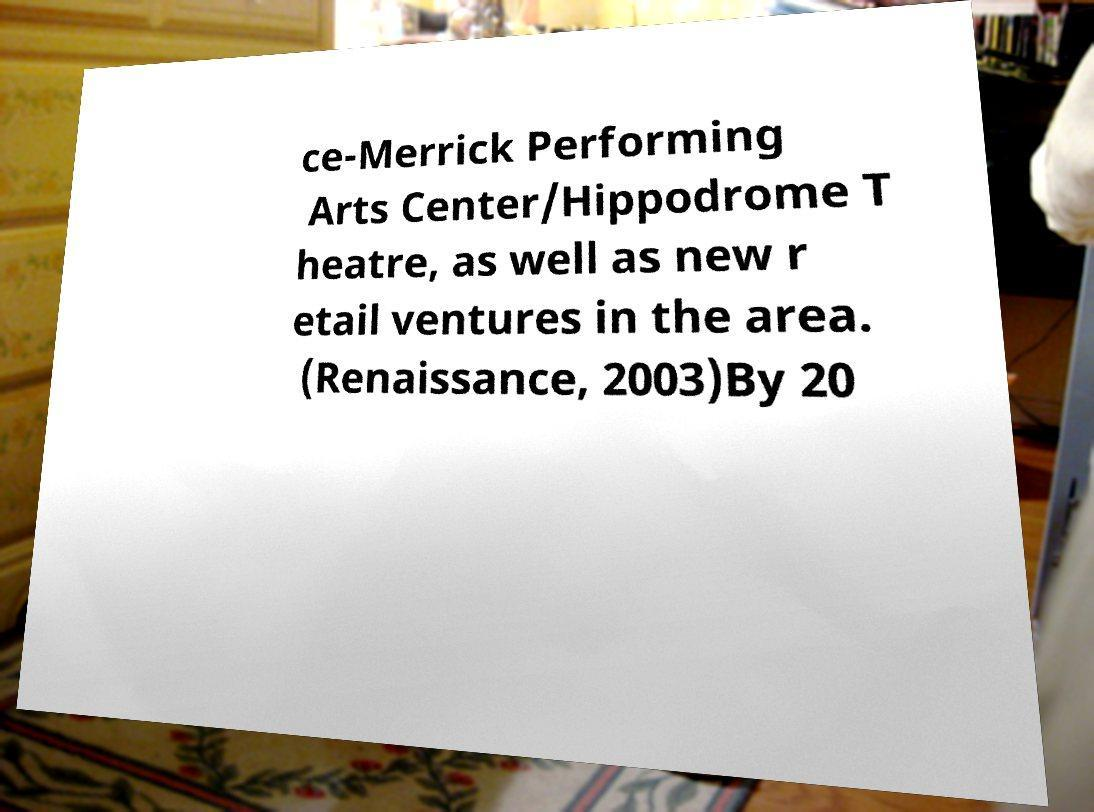Please identify and transcribe the text found in this image. ce-Merrick Performing Arts Center/Hippodrome T heatre, as well as new r etail ventures in the area. (Renaissance, 2003)By 20 